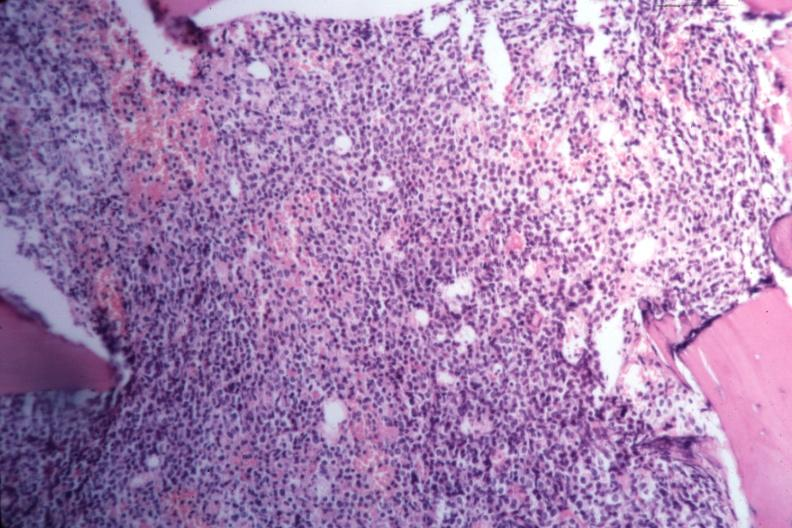s bone marrow present?
Answer the question using a single word or phrase. Yes 